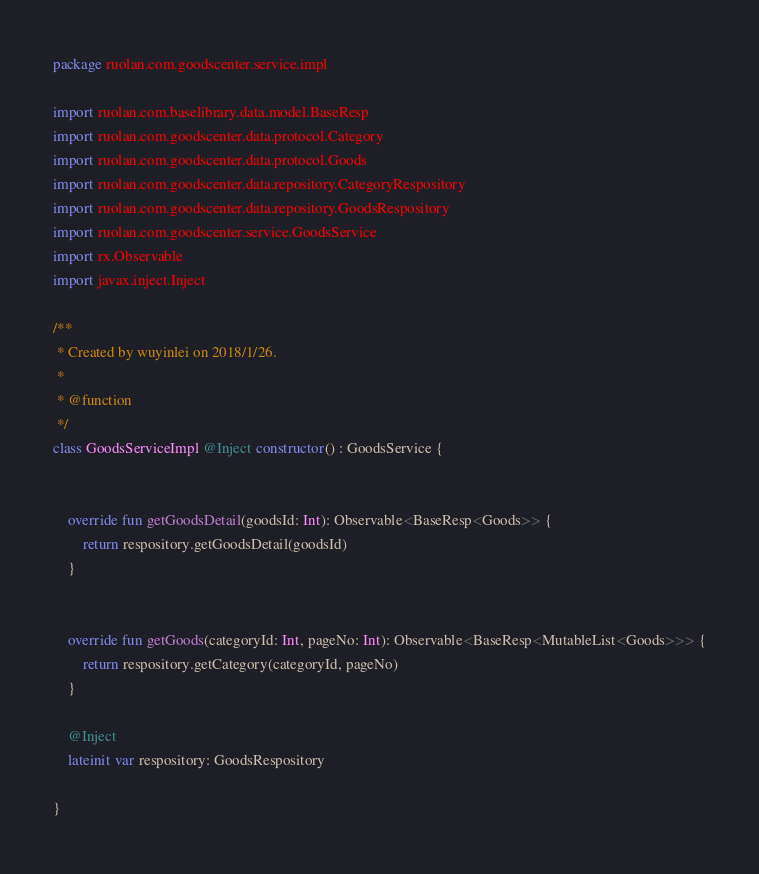<code> <loc_0><loc_0><loc_500><loc_500><_Kotlin_>package ruolan.com.goodscenter.service.impl

import ruolan.com.baselibrary.data.model.BaseResp
import ruolan.com.goodscenter.data.protocol.Category
import ruolan.com.goodscenter.data.protocol.Goods
import ruolan.com.goodscenter.data.repository.CategoryRespository
import ruolan.com.goodscenter.data.repository.GoodsRespository
import ruolan.com.goodscenter.service.GoodsService
import rx.Observable
import javax.inject.Inject

/**
 * Created by wuyinlei on 2018/1/26.
 *
 * @function
 */
class GoodsServiceImpl @Inject constructor() : GoodsService {


    override fun getGoodsDetail(goodsId: Int): Observable<BaseResp<Goods>> {
        return respository.getGoodsDetail(goodsId)
    }


    override fun getGoods(categoryId: Int, pageNo: Int): Observable<BaseResp<MutableList<Goods>>> {
        return respository.getCategory(categoryId, pageNo)
    }

    @Inject
    lateinit var respository: GoodsRespository

}</code> 